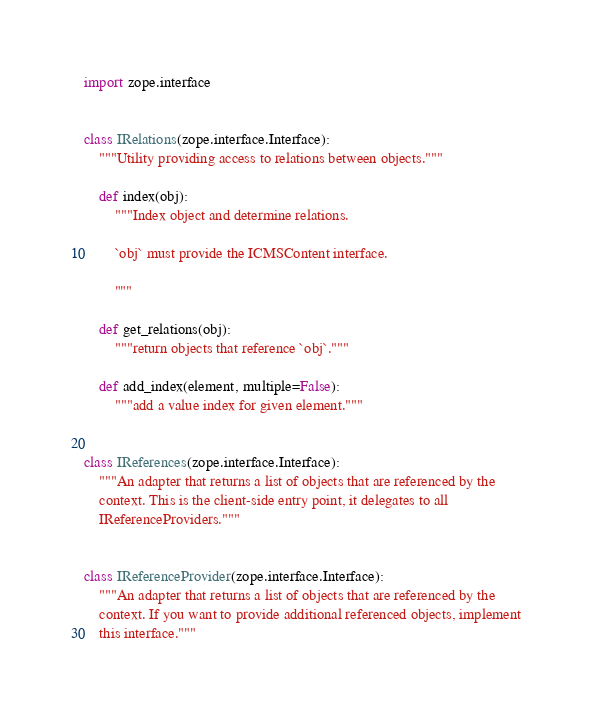Convert code to text. <code><loc_0><loc_0><loc_500><loc_500><_Python_>import zope.interface


class IRelations(zope.interface.Interface):
    """Utility providing access to relations between objects."""

    def index(obj):
        """Index object and determine relations.

        `obj` must provide the ICMSContent interface.

        """

    def get_relations(obj):
        """return objects that reference `obj`."""

    def add_index(element, multiple=False):
        """add a value index for given element."""


class IReferences(zope.interface.Interface):
    """An adapter that returns a list of objects that are referenced by the
    context. This is the client-side entry point, it delegates to all
    IReferenceProviders."""


class IReferenceProvider(zope.interface.Interface):
    """An adapter that returns a list of objects that are referenced by the
    context. If you want to provide additional referenced objects, implement
    this interface."""
</code> 